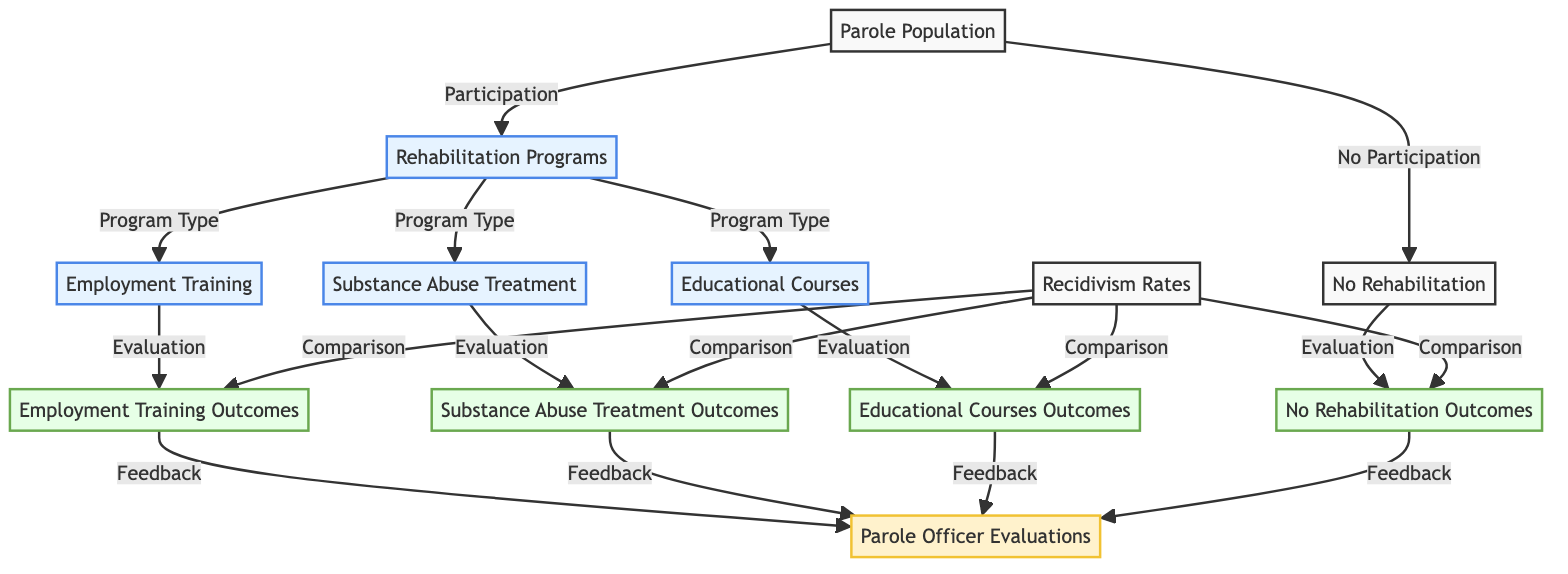What is the starting point of the flowchart? The flowchart begins with the "Parole Population" node, indicating the total number of parolees being analyzed.
Answer: Parole Population How many types of rehabilitation programs are identified in the diagram? There are three specific types of rehabilitation programs identified: Employment Training, Substance Abuse Treatment, and Educational Courses.
Answer: Three What follows "No Rehabilitation" in the flowchart? After "No Rehabilitation," the flow proceeds to the "No Rehabilitation Outcomes" node, which evaluates the outcomes for that group.
Answer: No Rehabilitation Outcomes What do all the rehabilitation programs lead to? All rehabilitation programs lead to the corresponding outcomes: Employment Training Outcomes, Substance Abuse Treatment Outcomes, and Educational Courses Outcomes.
Answer: Outcomes How are outcomes compared in the diagram? The "Recidivism Rates" node serves as the comparison point for the outcomes of those who participated in rehabilitation programs versus those who did not.
Answer: Comparison Which node encompasses the feedback from all program evaluations? The node "Parole Officer Evaluations" encompasses feedback from the evaluations related to Employment Training, Substance Abuse Treatment, Educational Courses, and No Rehabilitation.
Answer: Parole Officer Evaluations What is the flow direction from "Rehabilitation Programs" to the types of programs? The flow direction is from the node "Rehabilitation Programs" and splits into three branches: Employment Training, Substance Abuse Treatment, and Educational Courses based on the type of program.
Answer: Splits into three branches What are the two main categories of the population illustrated in the flowchart? The two main categories are parolees who participate in rehabilitation programs and those who do not participate, leading to distinct evaluations and outcomes.
Answer: Participation and No Participation 